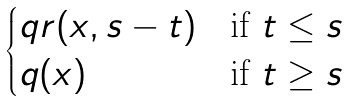<formula> <loc_0><loc_0><loc_500><loc_500>\begin{cases} q r ( x , s - t ) & \text {if $t \leq s$} \\ q ( x ) & \text {if $t\geq s$} \end{cases}</formula> 